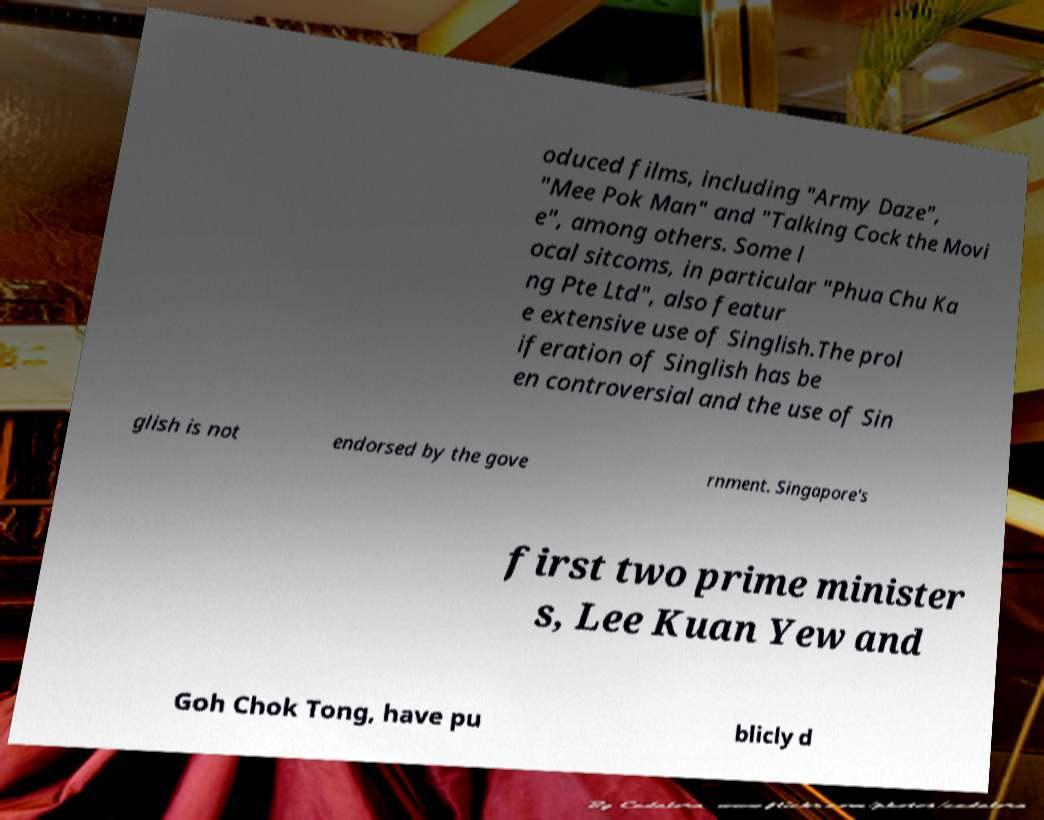Could you assist in decoding the text presented in this image and type it out clearly? oduced films, including "Army Daze", "Mee Pok Man" and "Talking Cock the Movi e", among others. Some l ocal sitcoms, in particular "Phua Chu Ka ng Pte Ltd", also featur e extensive use of Singlish.The prol iferation of Singlish has be en controversial and the use of Sin glish is not endorsed by the gove rnment. Singapore's first two prime minister s, Lee Kuan Yew and Goh Chok Tong, have pu blicly d 